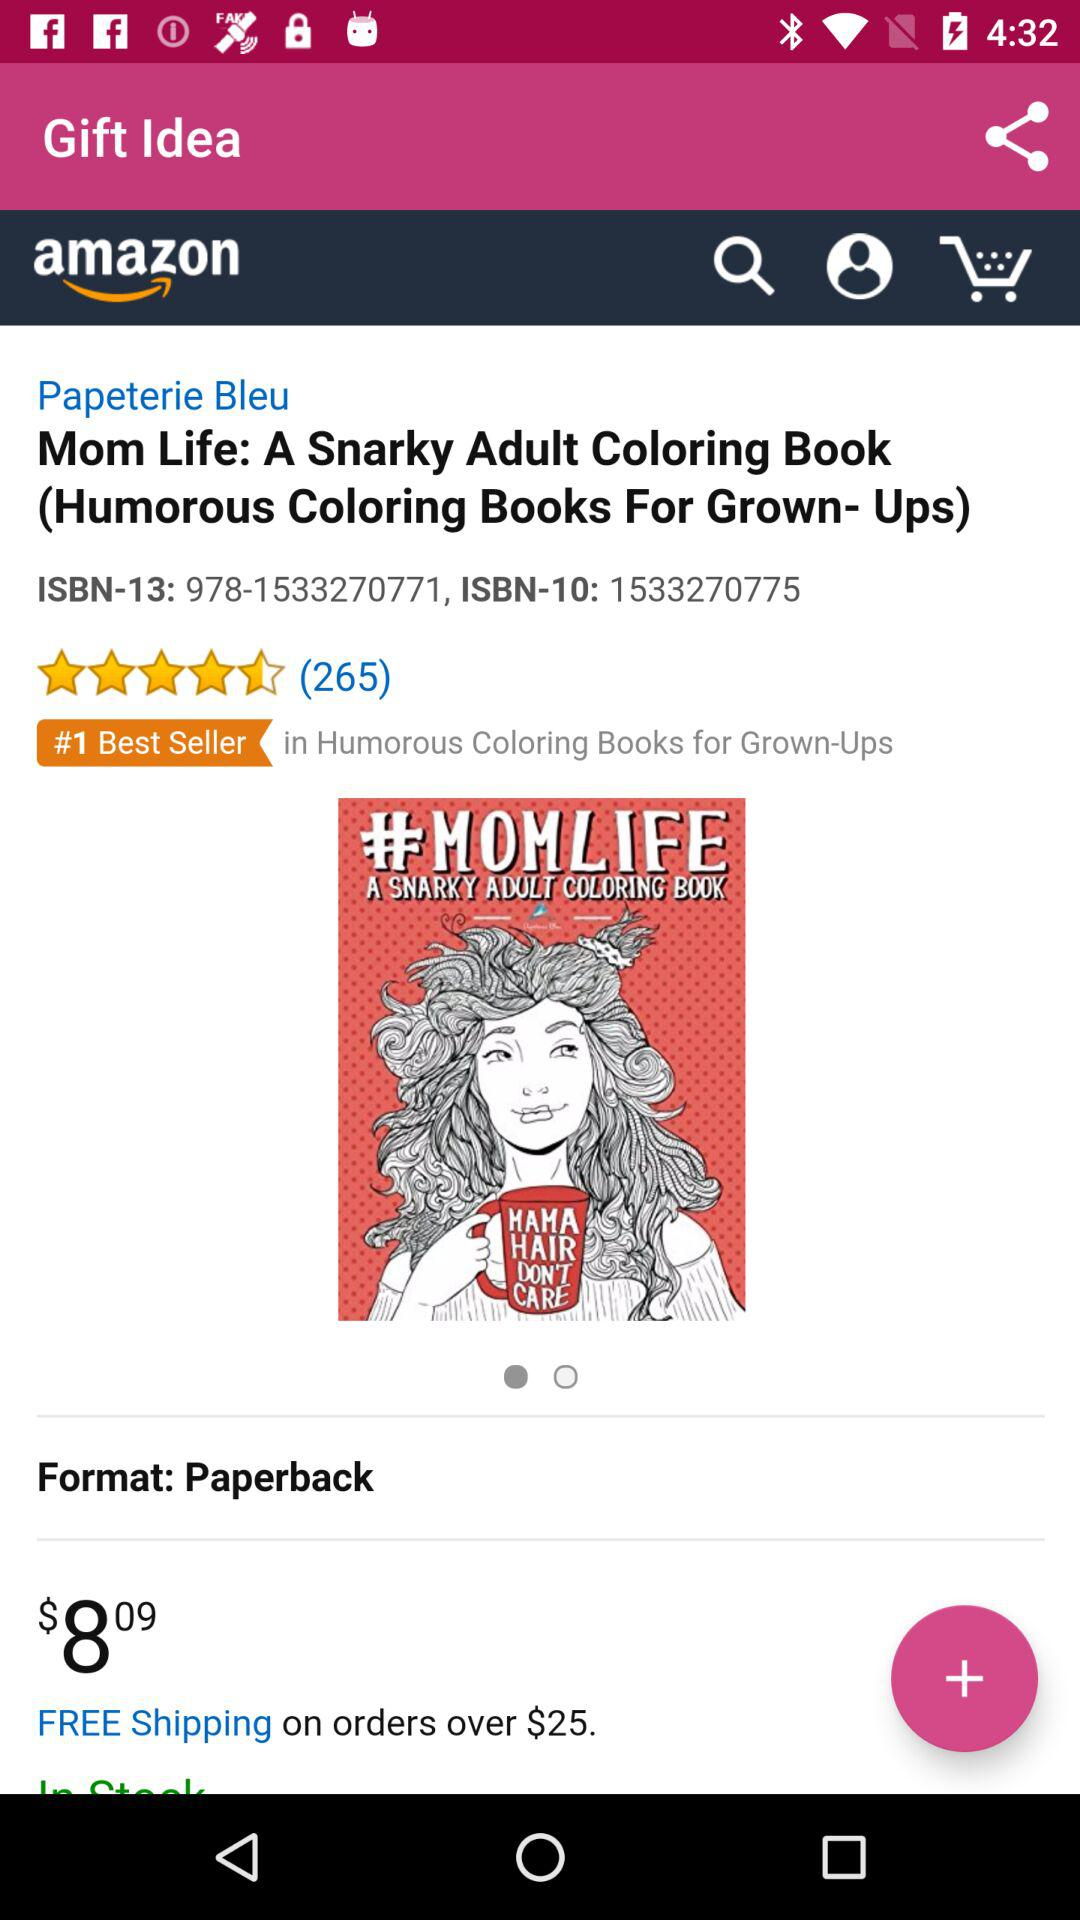What is the app name? The app name is "Gift Idea". 